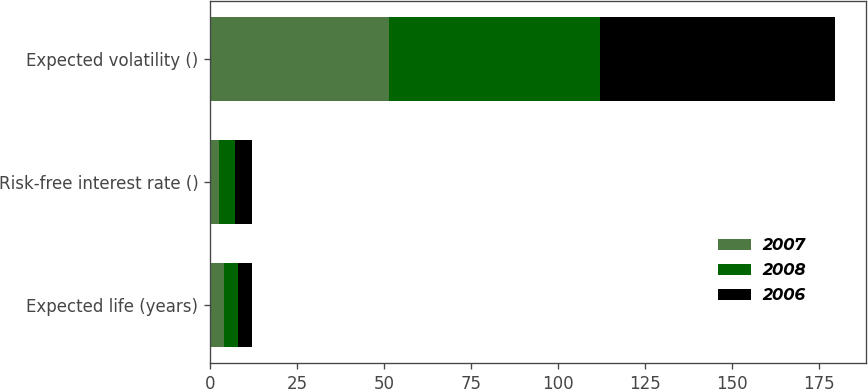Convert chart. <chart><loc_0><loc_0><loc_500><loc_500><stacked_bar_chart><ecel><fcel>Expected life (years)<fcel>Risk-free interest rate ()<fcel>Expected volatility ()<nl><fcel>2007<fcel>4.1<fcel>2.7<fcel>51.5<nl><fcel>2008<fcel>4<fcel>4.5<fcel>60.5<nl><fcel>2006<fcel>3.9<fcel>4.7<fcel>67.5<nl></chart> 